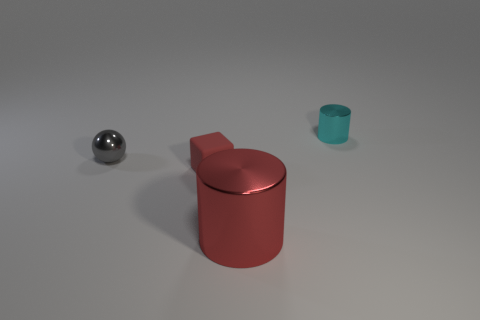Could the cylinder and the ball serve any specific functions given their shapes and textures? The cylindrical object, with its reflective lid, could resemble a storage container, perhaps for food or small items. The reflective ball, while simple, could serve as a decorative item or be part of a larger mechanical apparatus. What might this say about their use or the setting they are in? Their minimalist design and the clean, uncluttered setting could hint at a functional, modern environment—perhaps a setting that values simplicity or where these items serve as models or prototypes. 